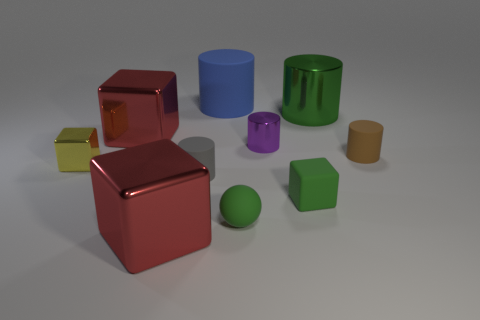Subtract all cyan cylinders. Subtract all green balls. How many cylinders are left? 5 Subtract all balls. How many objects are left? 9 Add 3 small brown rubber cylinders. How many small brown rubber cylinders are left? 4 Add 3 tiny rubber objects. How many tiny rubber objects exist? 7 Subtract 1 brown cylinders. How many objects are left? 9 Subtract all tiny gray matte cylinders. Subtract all brown things. How many objects are left? 8 